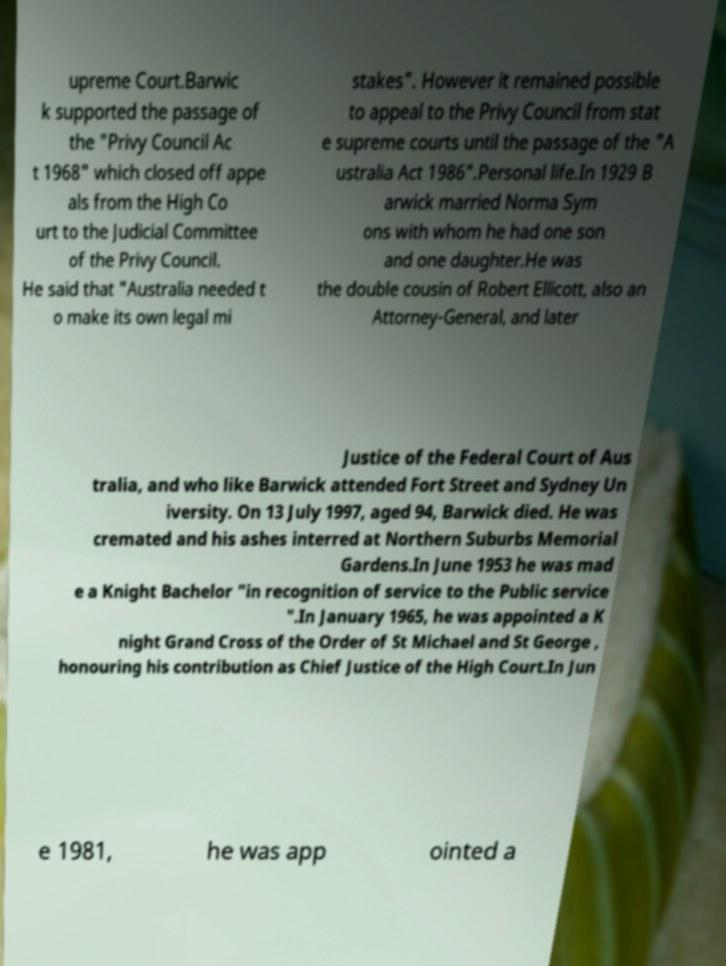There's text embedded in this image that I need extracted. Can you transcribe it verbatim? upreme Court.Barwic k supported the passage of the "Privy Council Ac t 1968" which closed off appe als from the High Co urt to the Judicial Committee of the Privy Council. He said that "Australia needed t o make its own legal mi stakes". However it remained possible to appeal to the Privy Council from stat e supreme courts until the passage of the "A ustralia Act 1986".Personal life.In 1929 B arwick married Norma Sym ons with whom he had one son and one daughter.He was the double cousin of Robert Ellicott, also an Attorney-General, and later Justice of the Federal Court of Aus tralia, and who like Barwick attended Fort Street and Sydney Un iversity. On 13 July 1997, aged 94, Barwick died. He was cremated and his ashes interred at Northern Suburbs Memorial Gardens.In June 1953 he was mad e a Knight Bachelor "in recognition of service to the Public service ".In January 1965, he was appointed a K night Grand Cross of the Order of St Michael and St George , honouring his contribution as Chief Justice of the High Court.In Jun e 1981, he was app ointed a 